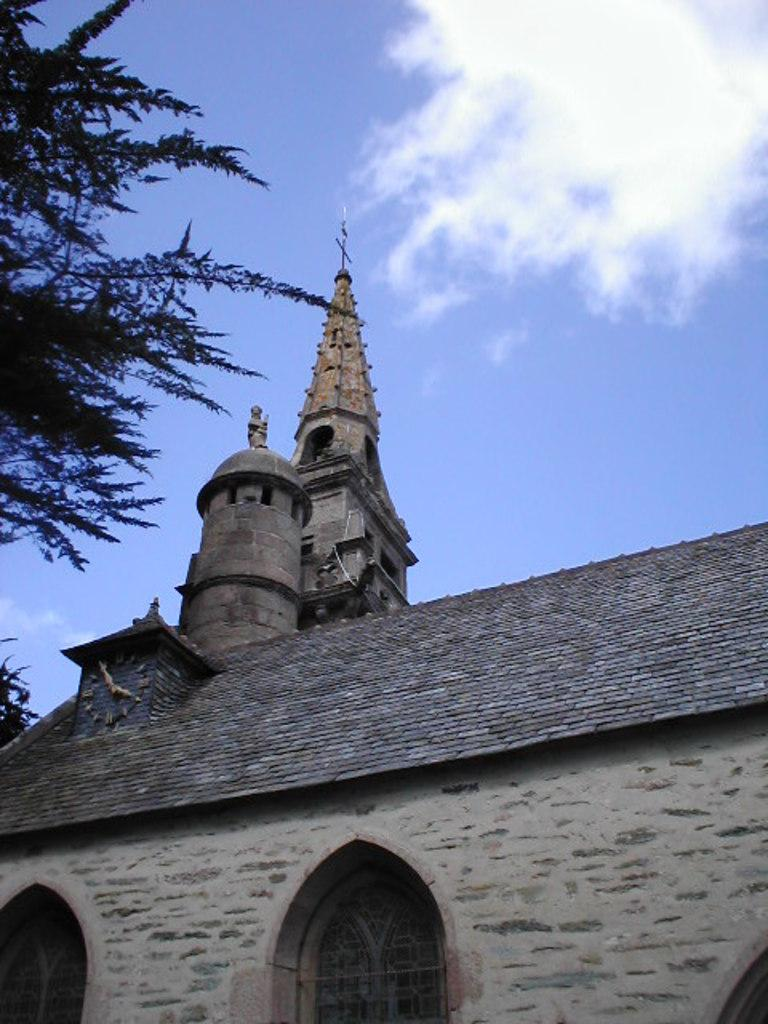What type of structure is present in the image? There is a building with windows in the image. What is located on the roof of the building? There is a clock on the roof of the building. What can be seen on the left side of the image? There is a tree on the left side of the image. What is visible in the background of the image? The sky is visible in the background of the image. What can be observed in the sky? There are clouds in the sky. Can you tell me what the dad is doing with the receipt in the image? There is no dad or receipt present in the image. What type of division is taking place in the image? There is no division or any indication of a division taking place in the image. 